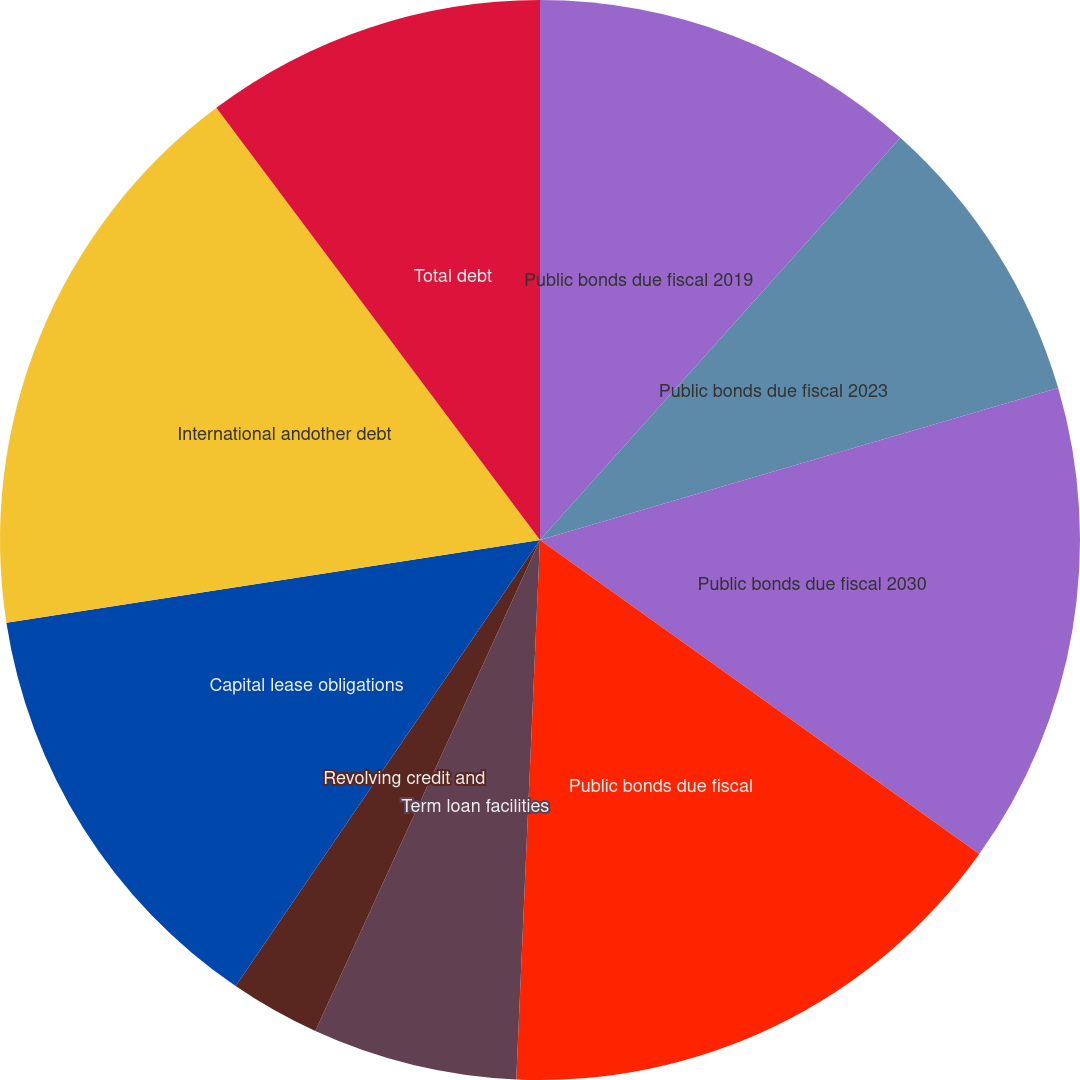Convert chart. <chart><loc_0><loc_0><loc_500><loc_500><pie_chart><fcel>Public bonds due fiscal 2019<fcel>Public bonds due fiscal 2023<fcel>Public bonds due fiscal 2030<fcel>Public bonds due fiscal<fcel>Term loan facilities<fcel>Revolving credit and<fcel>Capital lease obligations<fcel>International andother debt<fcel>Total debt<nl><fcel>11.63%<fcel>8.83%<fcel>14.42%<fcel>15.82%<fcel>6.13%<fcel>2.7%<fcel>13.02%<fcel>17.22%<fcel>10.23%<nl></chart> 